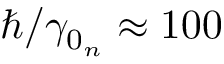Convert formula to latex. <formula><loc_0><loc_0><loc_500><loc_500>\hslash / \gamma _ { 0 _ { n } } \approx 1 0 0</formula> 